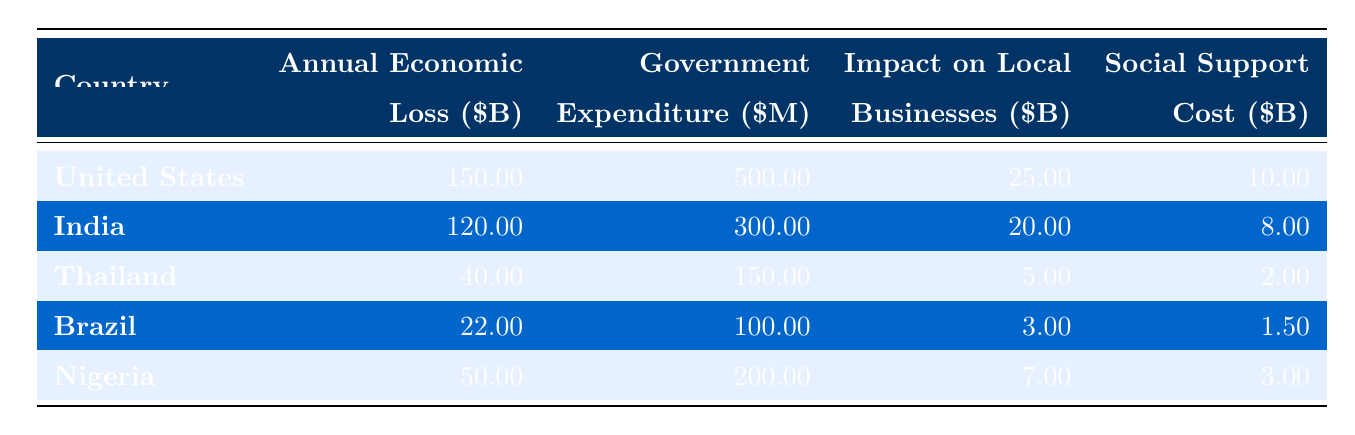What is the annual economic loss due to human trafficking in the United States? According to the table, the "Annual Economic Loss" for the United States is listed as 150 billion dollars.
Answer: 150 billion dollars How much does the government of India spend on counter-trafficking efforts? The table shows that the "Government Expenditure On Counter Trafficking" for India is 300 million dollars.
Answer: 300 million dollars Which country has the highest impact on local businesses? By reviewing the "Impact On Local Businesses" column, the United States has the highest figure at 25 billion dollars compared to the others.
Answer: United States What is the total annual economic loss for Nigeria and Brazil combined? Adding the annual economic loss for Nigeria (50 billion) and Brazil (22 billion) gives 50 + 22 = 72 billion dollars.
Answer: 72 billion dollars Is the social support cost higher in Thailand than in Brazil? The table lists the "Social Support Cost" for Thailand as 2 billion dollars and for Brazil as 1.5 billion dollars. Since 2 billion is greater than 1.5 billion, the statement is true.
Answer: Yes What is the average government expenditure on counter-trafficking across all listed countries? The government expenditures are 500 million (USA) + 300 million (India) + 150 million (Thailand) + 100 million (Brazil) + 200 million (Nigeria), totaling 1.3 billion divided by 5 gives an average of 260 million.
Answer: 260 million dollars Which country experiences an economic loss greater than 50 billion dollars? From the annual economic loss data, only the United States (150 billion) and India (120 billion) have losses exceeding 50 billion dollars.
Answer: United States, India What social support cost is associated with India? The table indicates that the "Social Support Cost" for India is 8 billion dollars.
Answer: 8 billion dollars If we consider the total economic loss and the government expenditure for counter-trafficking in Thailand, what ratio do they have? For Thailand, the total economic loss is 40 billion and the government expenditure is 150 million (0.15 billion). The ratio is 40/0.15 = approximately 267. Therefore, the ratio of economic loss to government expenditure is 267:1.
Answer: 267:1 